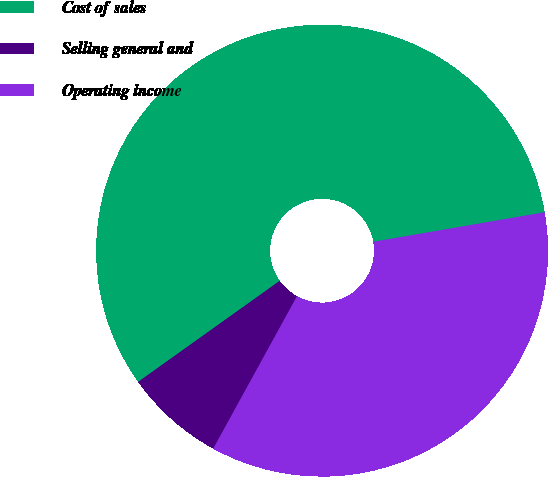Convert chart to OTSL. <chart><loc_0><loc_0><loc_500><loc_500><pie_chart><fcel>Cost of sales<fcel>Selling general and<fcel>Operating income<nl><fcel>57.14%<fcel>7.14%<fcel>35.71%<nl></chart> 